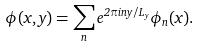<formula> <loc_0><loc_0><loc_500><loc_500>\phi ( x , y ) = \sum _ { n } e ^ { 2 \pi i n y / L _ { y } } \phi _ { n } ( x ) .</formula> 